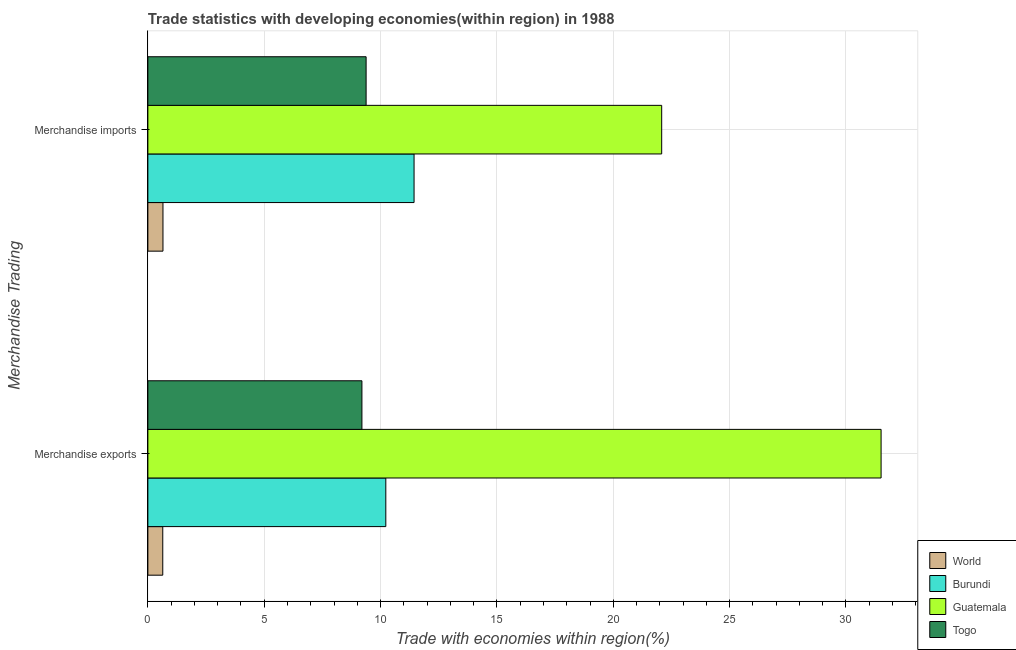What is the merchandise imports in Guatemala?
Provide a succinct answer. 22.08. Across all countries, what is the maximum merchandise imports?
Make the answer very short. 22.08. Across all countries, what is the minimum merchandise exports?
Your answer should be compact. 0.64. In which country was the merchandise exports maximum?
Your answer should be compact. Guatemala. In which country was the merchandise imports minimum?
Make the answer very short. World. What is the total merchandise imports in the graph?
Make the answer very short. 43.55. What is the difference between the merchandise imports in Burundi and that in Togo?
Give a very brief answer. 2.06. What is the difference between the merchandise imports in World and the merchandise exports in Guatemala?
Provide a succinct answer. -30.86. What is the average merchandise imports per country?
Give a very brief answer. 10.89. What is the difference between the merchandise exports and merchandise imports in Guatemala?
Your answer should be compact. 9.43. In how many countries, is the merchandise exports greater than 14 %?
Offer a very short reply. 1. What is the ratio of the merchandise exports in World to that in Burundi?
Keep it short and to the point. 0.06. What does the 4th bar from the top in Merchandise imports represents?
Provide a short and direct response. World. What does the 4th bar from the bottom in Merchandise exports represents?
Your answer should be compact. Togo. Are the values on the major ticks of X-axis written in scientific E-notation?
Give a very brief answer. No. Does the graph contain grids?
Give a very brief answer. Yes. Where does the legend appear in the graph?
Offer a very short reply. Bottom right. How are the legend labels stacked?
Provide a succinct answer. Vertical. What is the title of the graph?
Offer a very short reply. Trade statistics with developing economies(within region) in 1988. What is the label or title of the X-axis?
Give a very brief answer. Trade with economies within region(%). What is the label or title of the Y-axis?
Provide a short and direct response. Merchandise Trading. What is the Trade with economies within region(%) of World in Merchandise exports?
Your answer should be compact. 0.64. What is the Trade with economies within region(%) of Burundi in Merchandise exports?
Give a very brief answer. 10.23. What is the Trade with economies within region(%) in Guatemala in Merchandise exports?
Offer a terse response. 31.51. What is the Trade with economies within region(%) of Togo in Merchandise exports?
Your answer should be very brief. 9.2. What is the Trade with economies within region(%) of World in Merchandise imports?
Keep it short and to the point. 0.65. What is the Trade with economies within region(%) in Burundi in Merchandise imports?
Offer a terse response. 11.44. What is the Trade with economies within region(%) of Guatemala in Merchandise imports?
Your answer should be very brief. 22.08. What is the Trade with economies within region(%) in Togo in Merchandise imports?
Offer a terse response. 9.38. Across all Merchandise Trading, what is the maximum Trade with economies within region(%) of World?
Provide a short and direct response. 0.65. Across all Merchandise Trading, what is the maximum Trade with economies within region(%) of Burundi?
Your response must be concise. 11.44. Across all Merchandise Trading, what is the maximum Trade with economies within region(%) of Guatemala?
Offer a terse response. 31.51. Across all Merchandise Trading, what is the maximum Trade with economies within region(%) of Togo?
Your answer should be very brief. 9.38. Across all Merchandise Trading, what is the minimum Trade with economies within region(%) of World?
Give a very brief answer. 0.64. Across all Merchandise Trading, what is the minimum Trade with economies within region(%) in Burundi?
Ensure brevity in your answer.  10.23. Across all Merchandise Trading, what is the minimum Trade with economies within region(%) of Guatemala?
Keep it short and to the point. 22.08. Across all Merchandise Trading, what is the minimum Trade with economies within region(%) in Togo?
Keep it short and to the point. 9.2. What is the total Trade with economies within region(%) in World in the graph?
Give a very brief answer. 1.29. What is the total Trade with economies within region(%) in Burundi in the graph?
Provide a short and direct response. 21.66. What is the total Trade with economies within region(%) in Guatemala in the graph?
Give a very brief answer. 53.59. What is the total Trade with economies within region(%) in Togo in the graph?
Your answer should be compact. 18.58. What is the difference between the Trade with economies within region(%) in World in Merchandise exports and that in Merchandise imports?
Make the answer very short. -0.01. What is the difference between the Trade with economies within region(%) in Burundi in Merchandise exports and that in Merchandise imports?
Keep it short and to the point. -1.21. What is the difference between the Trade with economies within region(%) of Guatemala in Merchandise exports and that in Merchandise imports?
Offer a terse response. 9.43. What is the difference between the Trade with economies within region(%) in Togo in Merchandise exports and that in Merchandise imports?
Provide a short and direct response. -0.18. What is the difference between the Trade with economies within region(%) of World in Merchandise exports and the Trade with economies within region(%) of Burundi in Merchandise imports?
Offer a terse response. -10.8. What is the difference between the Trade with economies within region(%) of World in Merchandise exports and the Trade with economies within region(%) of Guatemala in Merchandise imports?
Provide a short and direct response. -21.44. What is the difference between the Trade with economies within region(%) of World in Merchandise exports and the Trade with economies within region(%) of Togo in Merchandise imports?
Keep it short and to the point. -8.74. What is the difference between the Trade with economies within region(%) in Burundi in Merchandise exports and the Trade with economies within region(%) in Guatemala in Merchandise imports?
Your response must be concise. -11.85. What is the difference between the Trade with economies within region(%) of Burundi in Merchandise exports and the Trade with economies within region(%) of Togo in Merchandise imports?
Provide a succinct answer. 0.85. What is the difference between the Trade with economies within region(%) in Guatemala in Merchandise exports and the Trade with economies within region(%) in Togo in Merchandise imports?
Your answer should be very brief. 22.13. What is the average Trade with economies within region(%) in World per Merchandise Trading?
Offer a very short reply. 0.64. What is the average Trade with economies within region(%) of Burundi per Merchandise Trading?
Your answer should be compact. 10.83. What is the average Trade with economies within region(%) in Guatemala per Merchandise Trading?
Give a very brief answer. 26.79. What is the average Trade with economies within region(%) in Togo per Merchandise Trading?
Offer a very short reply. 9.29. What is the difference between the Trade with economies within region(%) of World and Trade with economies within region(%) of Burundi in Merchandise exports?
Offer a very short reply. -9.58. What is the difference between the Trade with economies within region(%) in World and Trade with economies within region(%) in Guatemala in Merchandise exports?
Make the answer very short. -30.87. What is the difference between the Trade with economies within region(%) of World and Trade with economies within region(%) of Togo in Merchandise exports?
Provide a succinct answer. -8.56. What is the difference between the Trade with economies within region(%) of Burundi and Trade with economies within region(%) of Guatemala in Merchandise exports?
Your answer should be very brief. -21.28. What is the difference between the Trade with economies within region(%) in Burundi and Trade with economies within region(%) in Togo in Merchandise exports?
Give a very brief answer. 1.03. What is the difference between the Trade with economies within region(%) of Guatemala and Trade with economies within region(%) of Togo in Merchandise exports?
Your response must be concise. 22.31. What is the difference between the Trade with economies within region(%) of World and Trade with economies within region(%) of Burundi in Merchandise imports?
Give a very brief answer. -10.79. What is the difference between the Trade with economies within region(%) in World and Trade with economies within region(%) in Guatemala in Merchandise imports?
Ensure brevity in your answer.  -21.43. What is the difference between the Trade with economies within region(%) of World and Trade with economies within region(%) of Togo in Merchandise imports?
Offer a very short reply. -8.73. What is the difference between the Trade with economies within region(%) of Burundi and Trade with economies within region(%) of Guatemala in Merchandise imports?
Your answer should be compact. -10.64. What is the difference between the Trade with economies within region(%) of Burundi and Trade with economies within region(%) of Togo in Merchandise imports?
Keep it short and to the point. 2.06. What is the difference between the Trade with economies within region(%) in Guatemala and Trade with economies within region(%) in Togo in Merchandise imports?
Provide a succinct answer. 12.7. What is the ratio of the Trade with economies within region(%) in World in Merchandise exports to that in Merchandise imports?
Offer a very short reply. 0.99. What is the ratio of the Trade with economies within region(%) in Burundi in Merchandise exports to that in Merchandise imports?
Your answer should be compact. 0.89. What is the ratio of the Trade with economies within region(%) of Guatemala in Merchandise exports to that in Merchandise imports?
Provide a succinct answer. 1.43. What is the ratio of the Trade with economies within region(%) in Togo in Merchandise exports to that in Merchandise imports?
Provide a short and direct response. 0.98. What is the difference between the highest and the second highest Trade with economies within region(%) in World?
Your response must be concise. 0.01. What is the difference between the highest and the second highest Trade with economies within region(%) in Burundi?
Make the answer very short. 1.21. What is the difference between the highest and the second highest Trade with economies within region(%) in Guatemala?
Provide a short and direct response. 9.43. What is the difference between the highest and the second highest Trade with economies within region(%) in Togo?
Provide a short and direct response. 0.18. What is the difference between the highest and the lowest Trade with economies within region(%) of World?
Your answer should be very brief. 0.01. What is the difference between the highest and the lowest Trade with economies within region(%) of Burundi?
Ensure brevity in your answer.  1.21. What is the difference between the highest and the lowest Trade with economies within region(%) of Guatemala?
Your answer should be very brief. 9.43. What is the difference between the highest and the lowest Trade with economies within region(%) of Togo?
Your answer should be very brief. 0.18. 